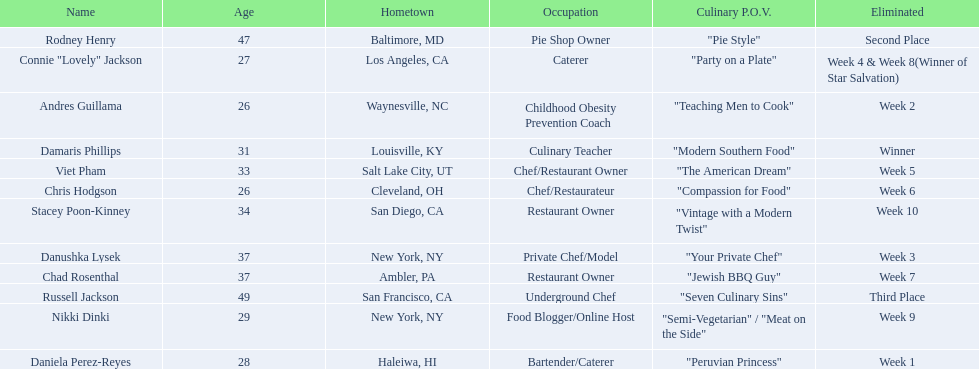Which competitor only lasted two weeks? Andres Guillama. Parse the table in full. {'header': ['Name', 'Age', 'Hometown', 'Occupation', 'Culinary P.O.V.', 'Eliminated'], 'rows': [['Rodney Henry', '47', 'Baltimore, MD', 'Pie Shop Owner', '"Pie Style"', 'Second Place'], ['Connie "Lovely" Jackson', '27', 'Los Angeles, CA', 'Caterer', '"Party on a Plate"', 'Week 4 & Week 8(Winner of Star Salvation)'], ['Andres Guillama', '26', 'Waynesville, NC', 'Childhood Obesity Prevention Coach', '"Teaching Men to Cook"', 'Week 2'], ['Damaris Phillips', '31', 'Louisville, KY', 'Culinary Teacher', '"Modern Southern Food"', 'Winner'], ['Viet Pham', '33', 'Salt Lake City, UT', 'Chef/Restaurant Owner', '"The American Dream"', 'Week 5'], ['Chris Hodgson', '26', 'Cleveland, OH', 'Chef/Restaurateur', '"Compassion for Food"', 'Week 6'], ['Stacey Poon-Kinney', '34', 'San Diego, CA', 'Restaurant Owner', '"Vintage with a Modern Twist"', 'Week 10'], ['Danushka Lysek', '37', 'New York, NY', 'Private Chef/Model', '"Your Private Chef"', 'Week 3'], ['Chad Rosenthal', '37', 'Ambler, PA', 'Restaurant Owner', '"Jewish BBQ Guy"', 'Week 7'], ['Russell Jackson', '49', 'San Francisco, CA', 'Underground Chef', '"Seven Culinary Sins"', 'Third Place'], ['Nikki Dinki', '29', 'New York, NY', 'Food Blogger/Online Host', '"Semi-Vegetarian" / "Meat on the Side"', 'Week 9'], ['Daniela Perez-Reyes', '28', 'Haleiwa, HI', 'Bartender/Caterer', '"Peruvian Princess"', 'Week 1']]} 